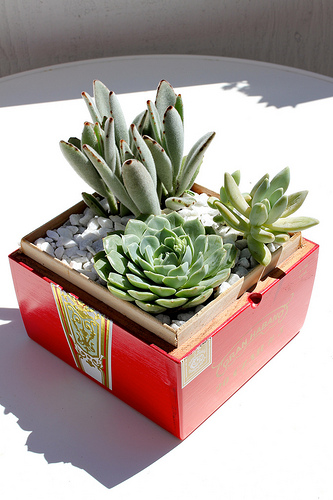<image>
Can you confirm if the shadow is on the table? Yes. Looking at the image, I can see the shadow is positioned on top of the table, with the table providing support. Is there a cactus on the box? Yes. Looking at the image, I can see the cactus is positioned on top of the box, with the box providing support. Is there a succulent above the box? Yes. The succulent is positioned above the box in the vertical space, higher up in the scene. 